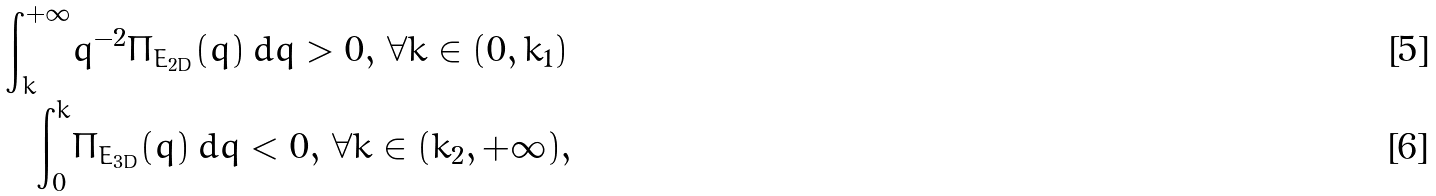<formula> <loc_0><loc_0><loc_500><loc_500>\int _ { k } ^ { + \infty } & q ^ { - 2 } \Pi _ { E _ { 2 D } } ( q ) \, d q > 0 , \, \forall k \in ( 0 , k _ { 1 } ) \\ \int _ { 0 } ^ { k } & \Pi _ { E _ { 3 D } } ( q ) \, d q < 0 , \, \forall k \in ( k _ { 2 } , + \infty ) ,</formula> 